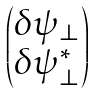<formula> <loc_0><loc_0><loc_500><loc_500>\begin{pmatrix} \delta \psi _ { \perp } \\ \delta \psi _ { \perp } ^ { * } \end{pmatrix}</formula> 